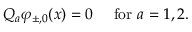<formula> <loc_0><loc_0><loc_500><loc_500>Q _ { a } \varphi _ { \pm , 0 } ( x ) = 0 f o r a = 1 , 2 .</formula> 